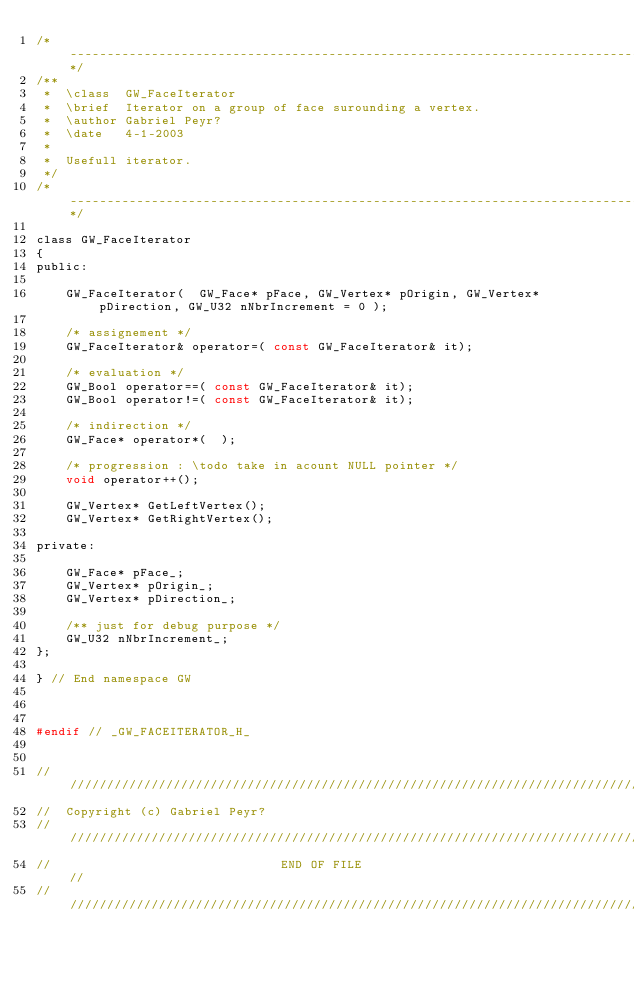Convert code to text. <code><loc_0><loc_0><loc_500><loc_500><_C_>/*------------------------------------------------------------------------------*/
/** 
 *  \class  GW_FaceIterator
 *  \brief  Iterator on a group of face surounding a vertex.
 *  \author Gabriel Peyr?
 *  \date   4-1-2003
 *
 *  Usefull iterator.
 */ 
/*------------------------------------------------------------------------------*/

class GW_FaceIterator
{
public:

	GW_FaceIterator(  GW_Face* pFace, GW_Vertex* pOrigin, GW_Vertex* pDirection, GW_U32 nNbrIncrement = 0 );

	/* assignement */
	GW_FaceIterator& operator=( const GW_FaceIterator& it);

	/* evaluation */
	GW_Bool operator==( const GW_FaceIterator& it);
	GW_Bool operator!=( const GW_FaceIterator& it);

	/* indirection */
	GW_Face* operator*(  );

	/* progression : \todo take in acount NULL pointer */
	void operator++();

	GW_Vertex* GetLeftVertex();
	GW_Vertex* GetRightVertex();

private:

	GW_Face* pFace_;
	GW_Vertex* pOrigin_;
	GW_Vertex* pDirection_;

	/** just for debug purpose */
	GW_U32 nNbrIncrement_;
};

} // End namespace GW



#endif // _GW_FACEITERATOR_H_


///////////////////////////////////////////////////////////////////////////////
//  Copyright (c) Gabriel Peyr?
///////////////////////////////////////////////////////////////////////////////
//                               END OF FILE                                 //
///////////////////////////////////////////////////////////////////////////////
</code> 